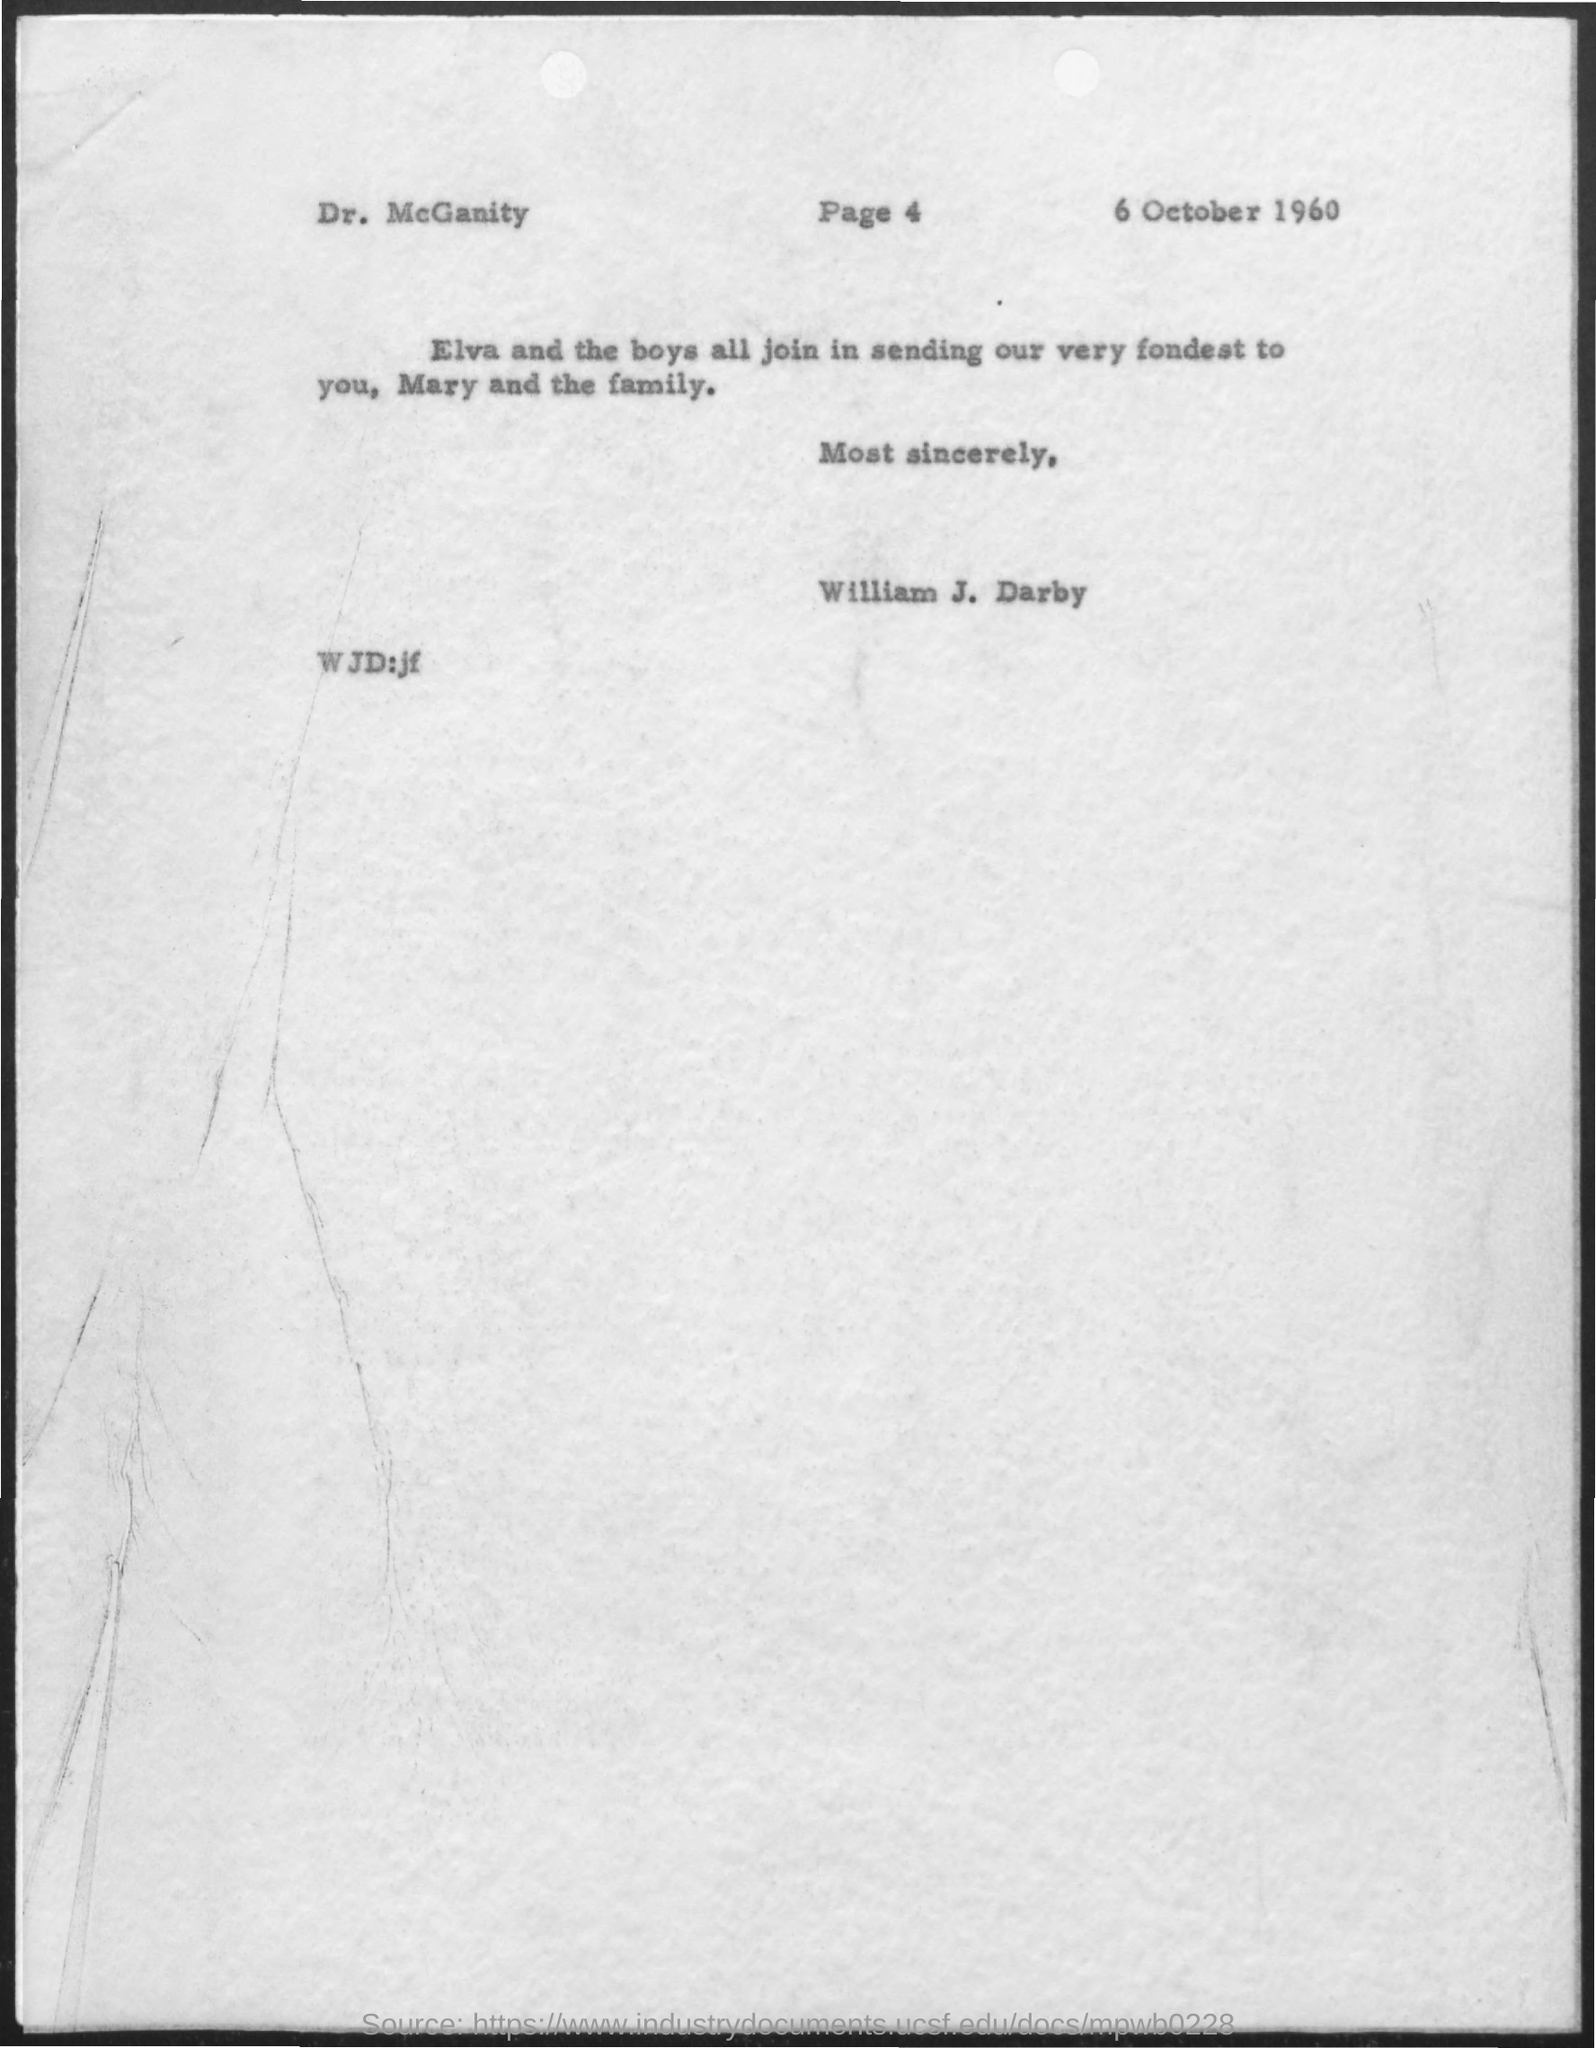Point out several critical features in this image. The addressee of this letter is Dr. McGanity. The letter is dated October 6, 1960. The letter is from William J. Darby. 